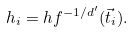<formula> <loc_0><loc_0><loc_500><loc_500>h _ { i } = h f ^ { - 1 / d ^ { \prime } } ( \vec { t } _ { i } ) .</formula> 